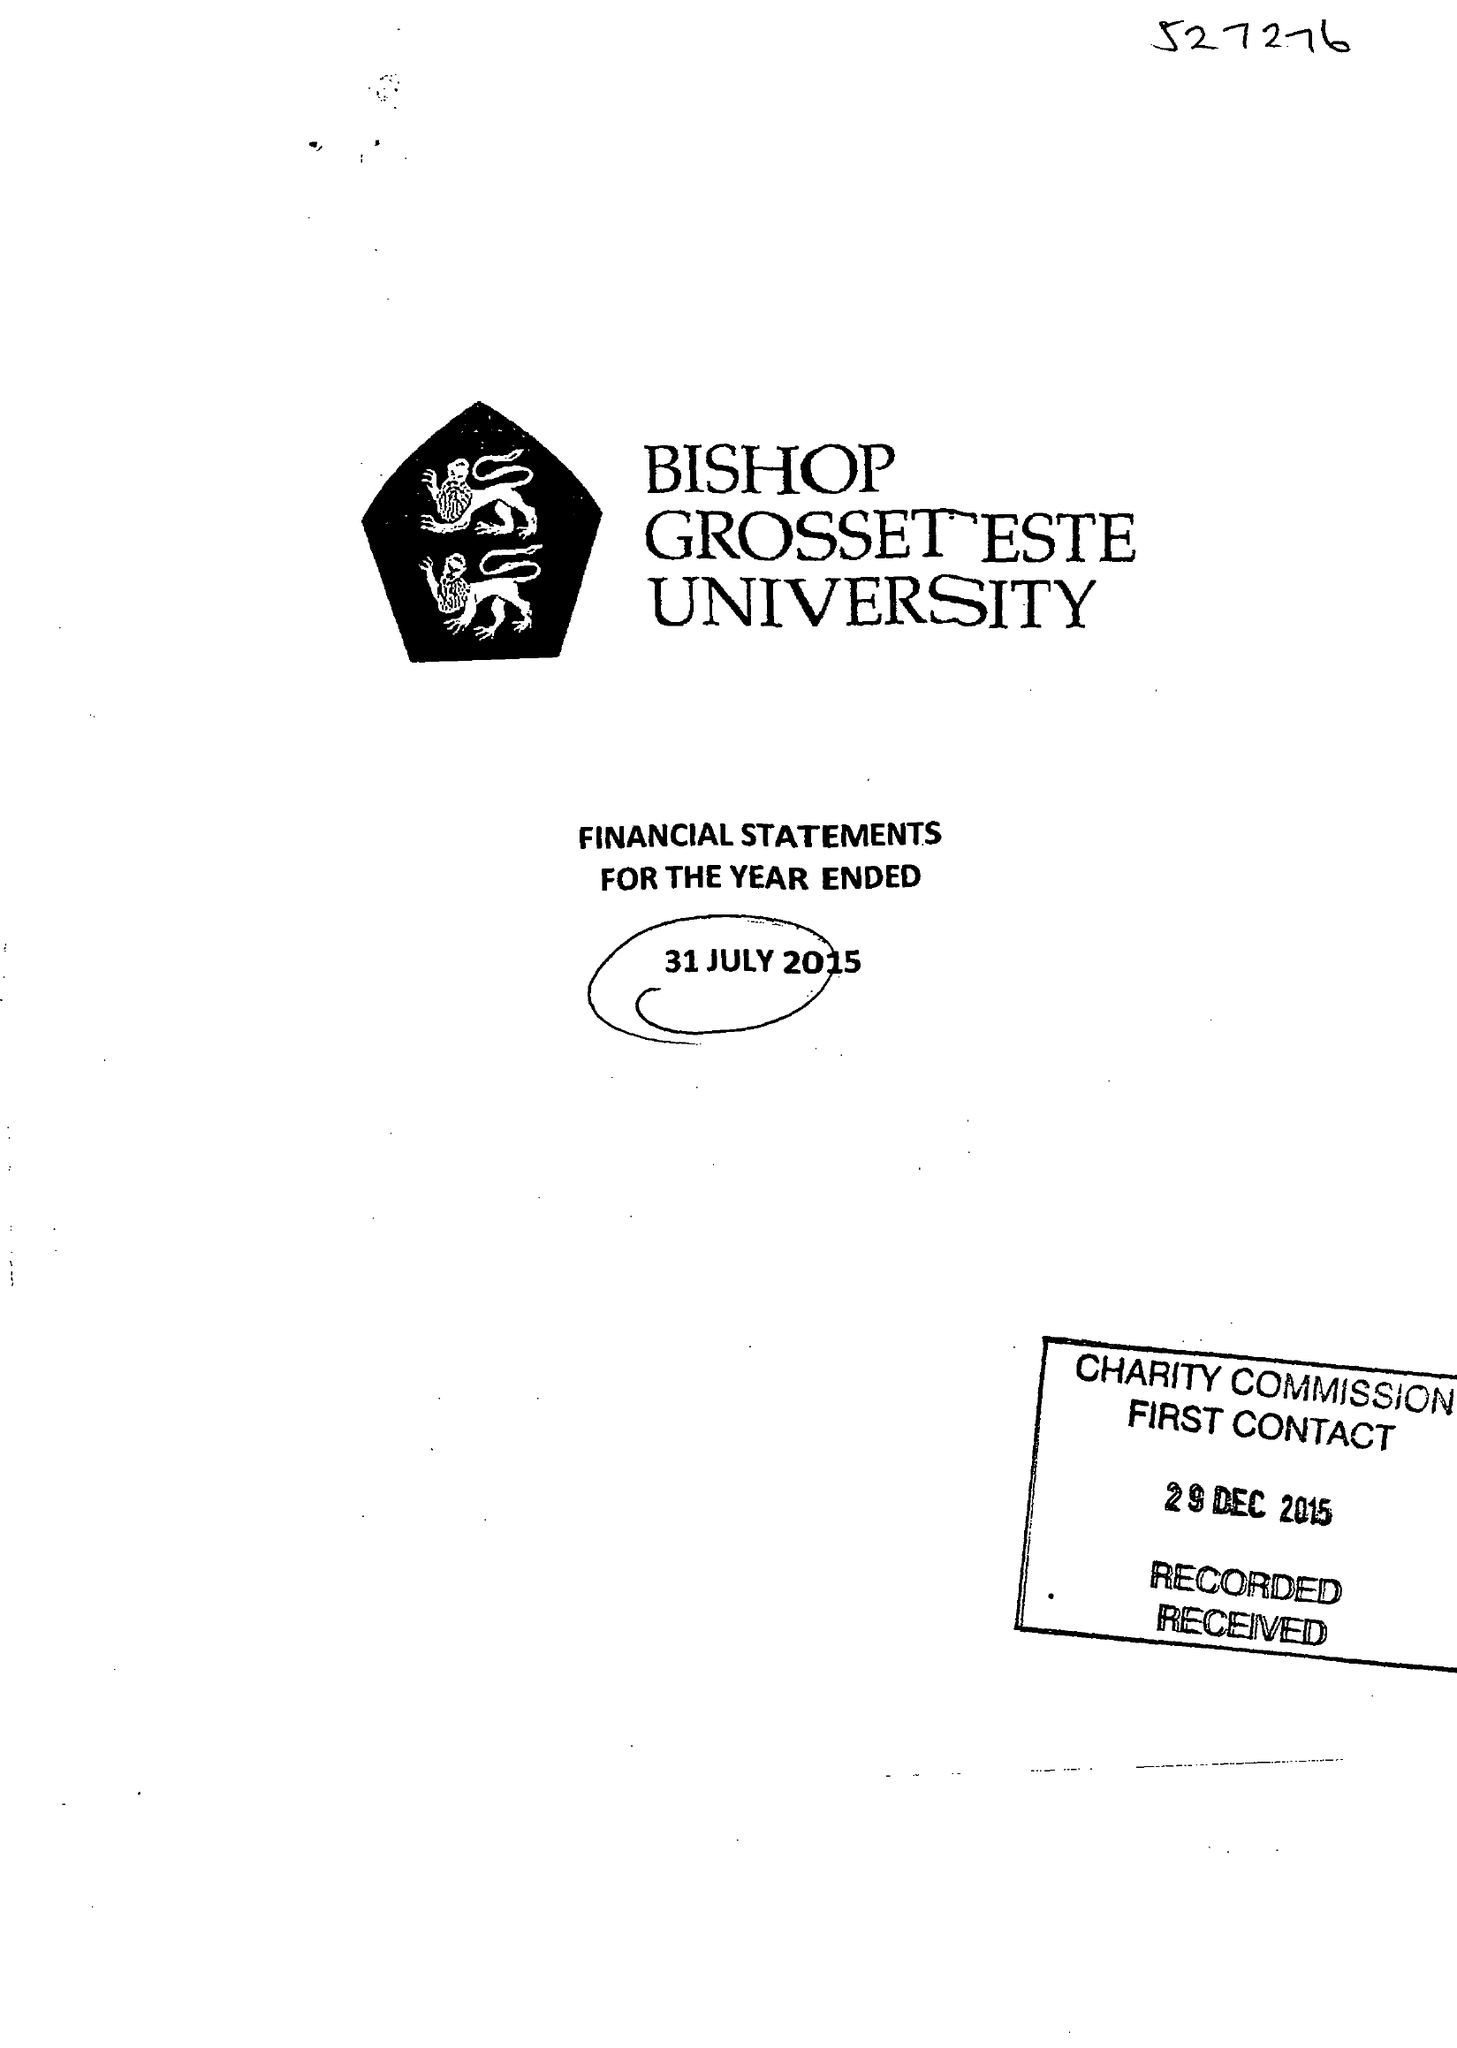What is the value for the charity_number?
Answer the question using a single word or phrase. 527276 